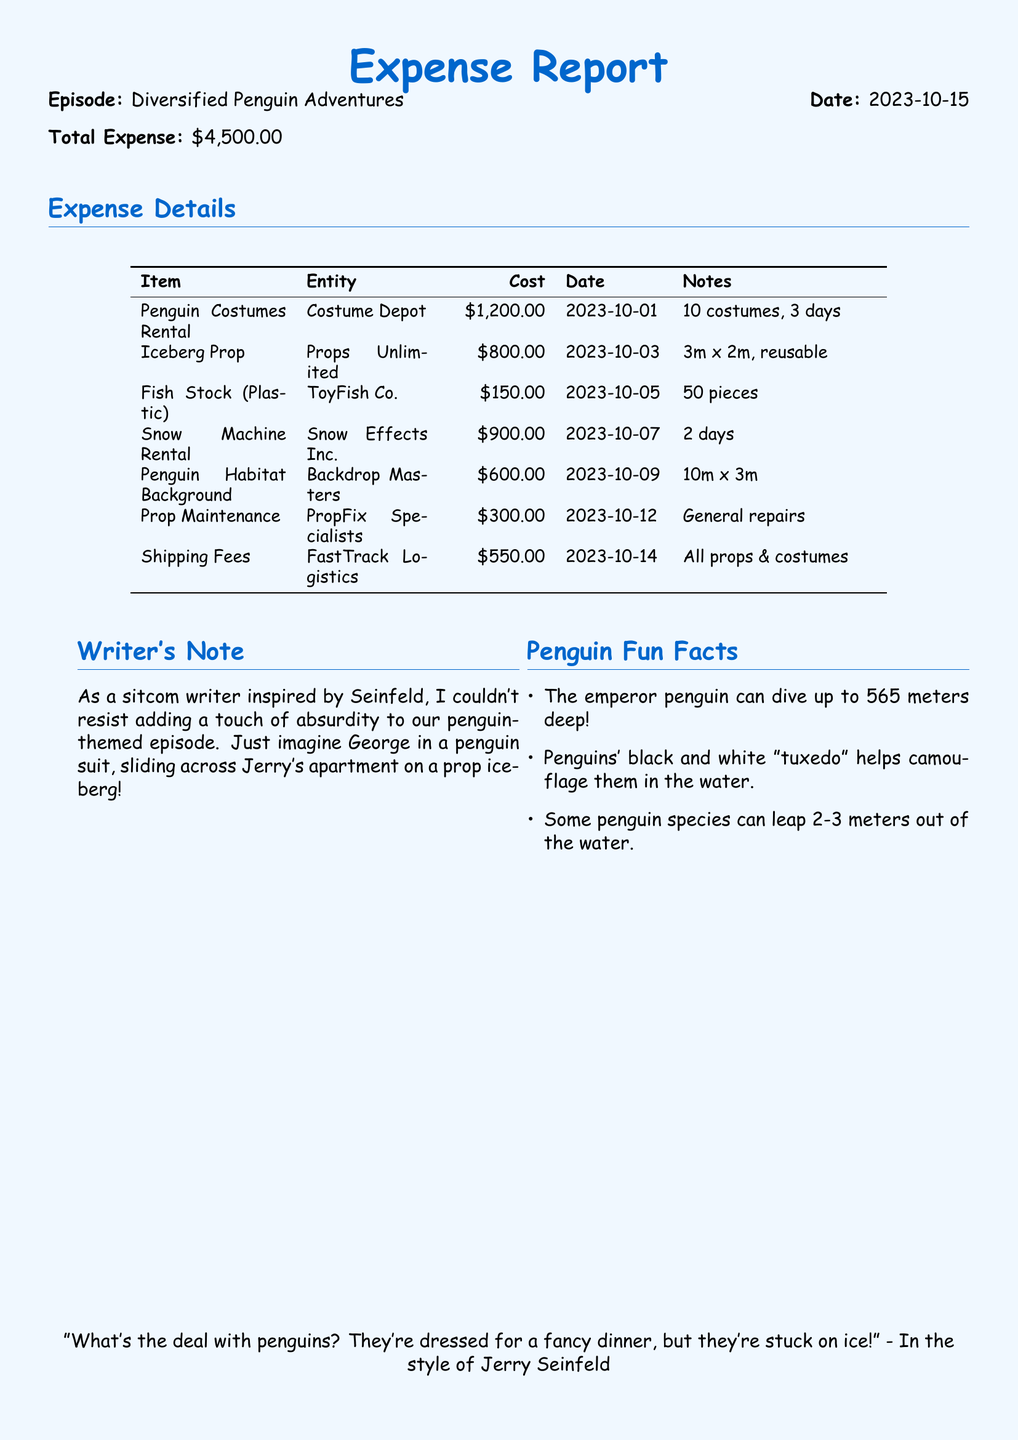what is the total expense? The total expense is stated at the top of the document.
Answer: $4,500.00 which entity provided the Penguin Costumes Rental? The document lists the entity associated with the Penguin Costumes Rental in the table.
Answer: Costume Depot how much did the Snow Machine Rental cost? The cost of the Snow Machine Rental is specified in the expense details.
Answer: $900.00 what date was the Iceberg Prop rented? The document includes rental dates for each item in the table.
Answer: 2023-10-03 how many plastic fish pieces were purchased? The document states the quantity of fish stock purchased under the expense details.
Answer: 50 pieces what was the purpose of the Prop Maintenance cost? The Notes column for Prop Maintenance explains the reason for the cost.
Answer: General repairs how many costumes were included in the Penguin Costumes Rental? The Notes for the Penguin Costumes Rental indicate the total number of costumes.
Answer: 10 costumes who did the shipping for all props and costumes? The entity responsible for shipping is mentioned in the expense details.
Answer: FastTrack Logistics what type of background was rented for the penguin-themed episode? The document describes the Penguin Habitat Background rented in the expense details.
Answer: Penguin Habitat Background 